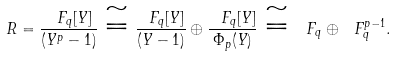<formula> <loc_0><loc_0><loc_500><loc_500>R = \frac { \ F _ { q } [ Y ] } { ( Y ^ { p } - 1 ) } \cong \frac { \ F _ { q } [ Y ] } { ( Y - 1 ) } \oplus \frac { \ F _ { q } [ Y ] } { \Phi _ { p } ( Y ) } \cong \ F _ { q } \oplus \ F _ { q } ^ { p - 1 } .</formula> 